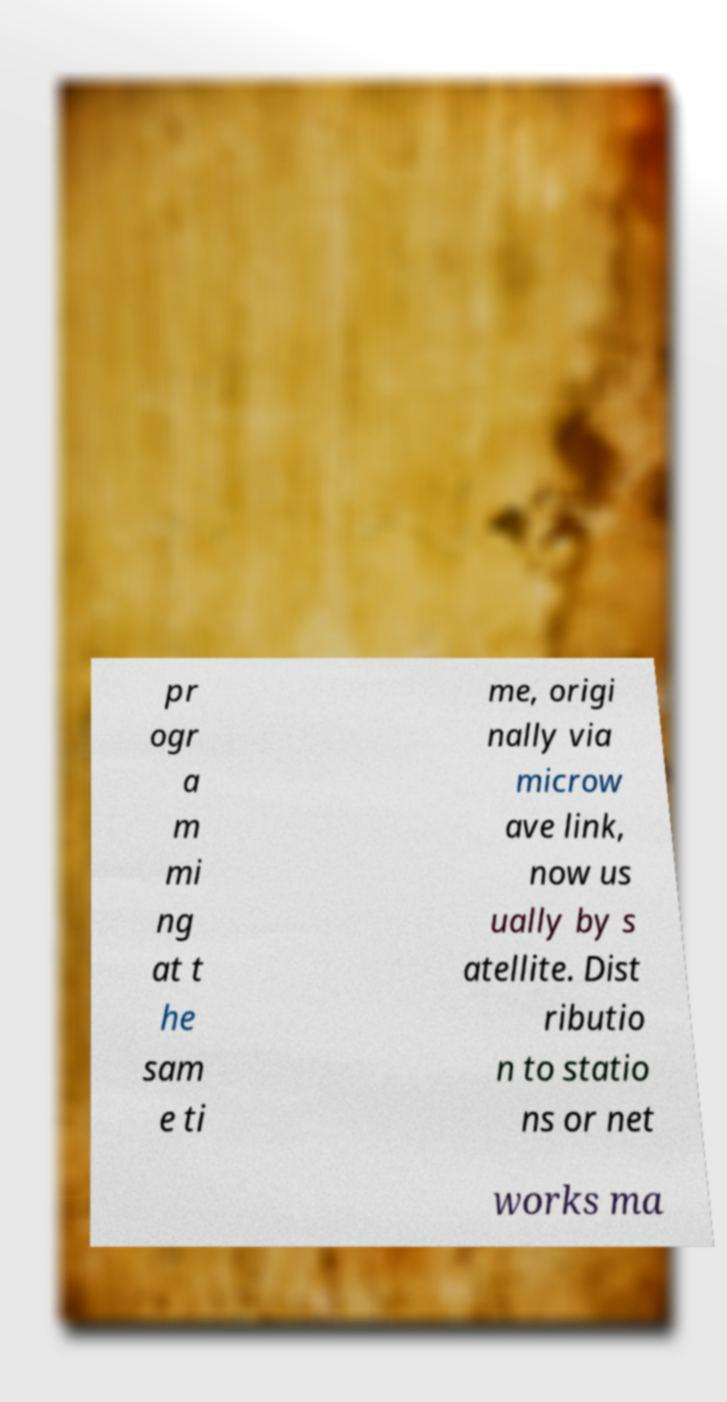Can you accurately transcribe the text from the provided image for me? pr ogr a m mi ng at t he sam e ti me, origi nally via microw ave link, now us ually by s atellite. Dist ributio n to statio ns or net works ma 